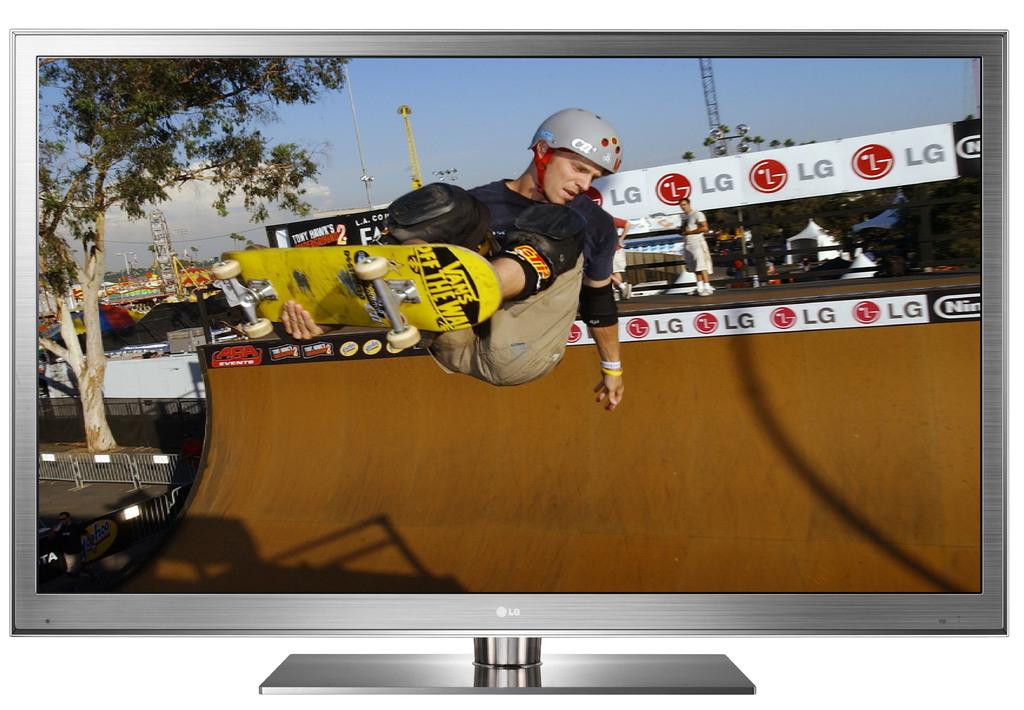Is lg a sponsor?
Your response must be concise. Yes. Is the word on the bottom of the monitor lg?
Provide a succinct answer. Yes. 